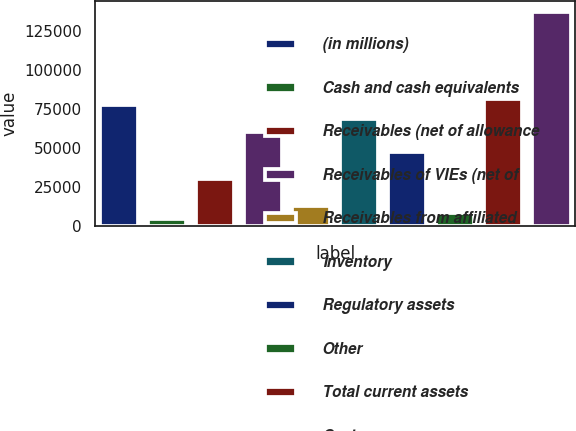<chart> <loc_0><loc_0><loc_500><loc_500><bar_chart><fcel>(in millions)<fcel>Cash and cash equivalents<fcel>Receivables (net of allowance<fcel>Receivables of VIEs (net of<fcel>Receivables from affiliated<fcel>Inventory<fcel>Regulatory assets<fcel>Other<fcel>Total current assets<fcel>Cost<nl><fcel>77284.6<fcel>4300.2<fcel>30059.4<fcel>60111.8<fcel>12886.6<fcel>68698.2<fcel>47232.2<fcel>8593.4<fcel>81577.8<fcel>137389<nl></chart> 